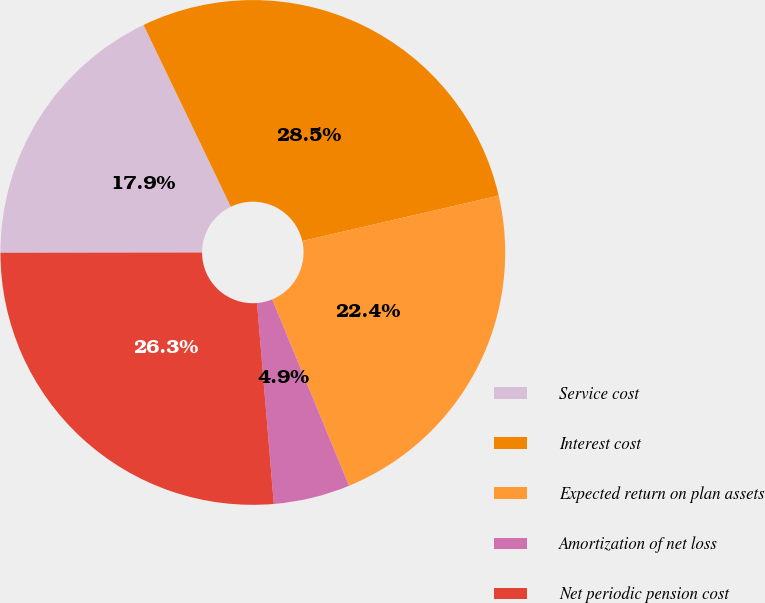Convert chart to OTSL. <chart><loc_0><loc_0><loc_500><loc_500><pie_chart><fcel>Service cost<fcel>Interest cost<fcel>Expected return on plan assets<fcel>Amortization of net loss<fcel>Net periodic pension cost<nl><fcel>17.89%<fcel>28.51%<fcel>22.39%<fcel>4.9%<fcel>26.31%<nl></chart> 